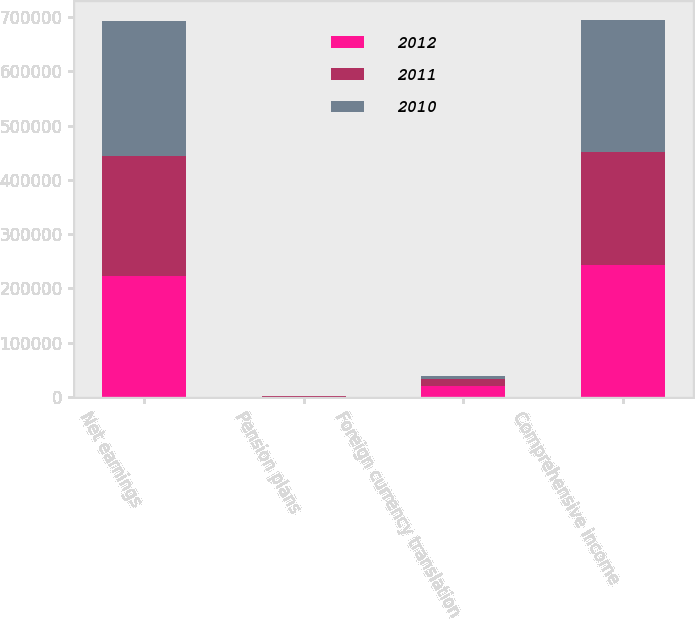Convert chart to OTSL. <chart><loc_0><loc_0><loc_500><loc_500><stacked_bar_chart><ecel><fcel>Net earnings<fcel>Pension plans<fcel>Foreign currency translation<fcel>Comprehensive income<nl><fcel>2012<fcel>222398<fcel>745<fcel>20790<fcel>243933<nl><fcel>2011<fcel>221474<fcel>1113<fcel>12533<fcel>207828<nl><fcel>2010<fcel>248126<fcel>664<fcel>6142<fcel>242648<nl></chart> 